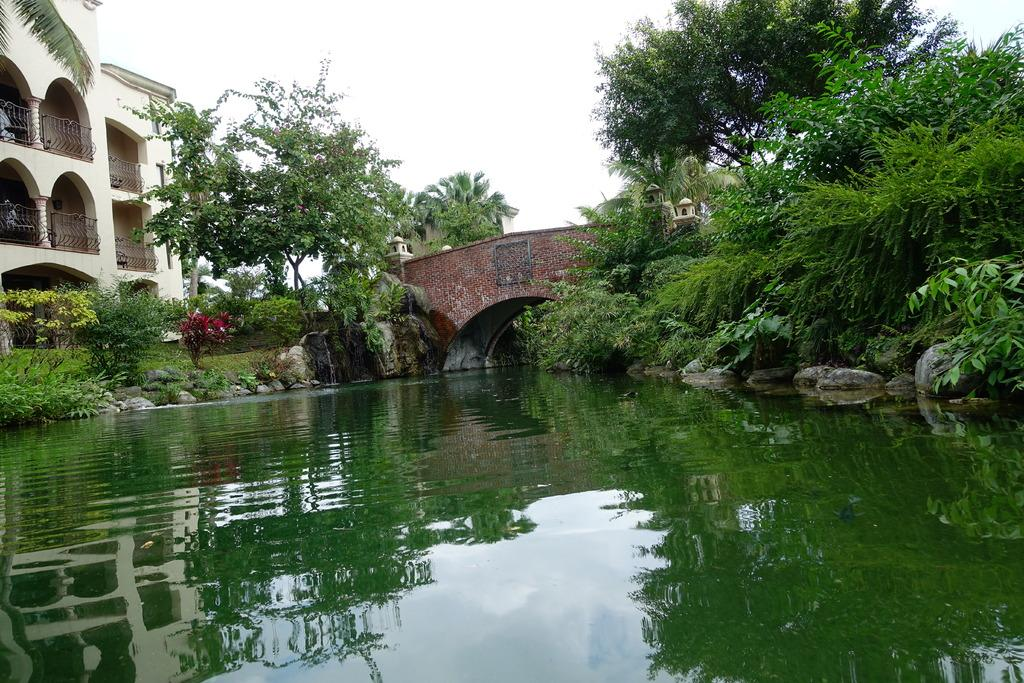What is the main object in the image? There is a pot in the image. What type of natural elements can be seen in the image? There are trees and plants in the image. What type of ground elements are present in the image? There are stones in the image. What type of man-made structure is visible in the image? There is a building in the image. In which direction is the river flowing in the image? There is no river present in the image. What type of straw is used to stir the pot in the image? There is no straw present in the image, and the pot does not require stirring. 